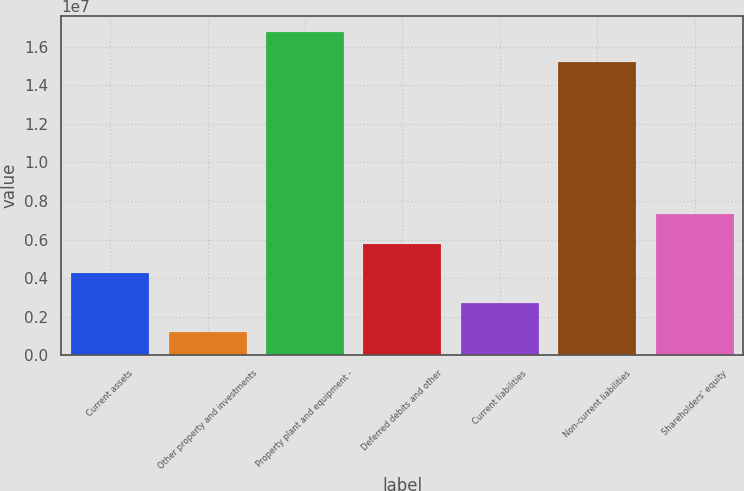Convert chart to OTSL. <chart><loc_0><loc_0><loc_500><loc_500><bar_chart><fcel>Current assets<fcel>Other property and investments<fcel>Property plant and equipment -<fcel>Deferred debits and other<fcel>Current liabilities<fcel>Non-current liabilities<fcel>Shareholders' equity<nl><fcel>4.26063e+06<fcel>1.20025e+06<fcel>1.67443e+07<fcel>5.79082e+06<fcel>2.73044e+06<fcel>1.52141e+07<fcel>7.32101e+06<nl></chart> 